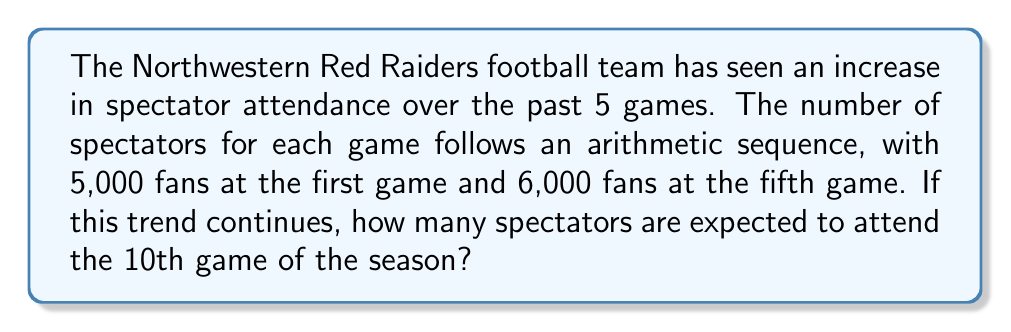Help me with this question. Let's solve this step-by-step:

1) First, we need to find the common difference (d) of the arithmetic sequence.
   We have:
   $a_1 = 5000$ (first term)
   $a_5 = 6000$ (fifth term)

2) In an arithmetic sequence, we can use the formula:
   $a_n = a_1 + (n-1)d$

3) Substituting our known values:
   $6000 = 5000 + (5-1)d$
   $6000 = 5000 + 4d$

4) Solving for d:
   $1000 = 4d$
   $d = 250$

5) Now that we have the common difference, we can find the number of spectators for the 10th game using the same formula:
   $a_{10} = a_1 + (10-1)d$
   $a_{10} = 5000 + 9(250)$
   $a_{10} = 5000 + 2250$
   $a_{10} = 7250$

Therefore, if the trend continues, 7,250 spectators are expected to attend the 10th game.
Answer: 7,250 spectators 